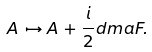<formula> <loc_0><loc_0><loc_500><loc_500>A \, \mapsto A \, + \frac { i } { 2 } d \i m a F .</formula> 